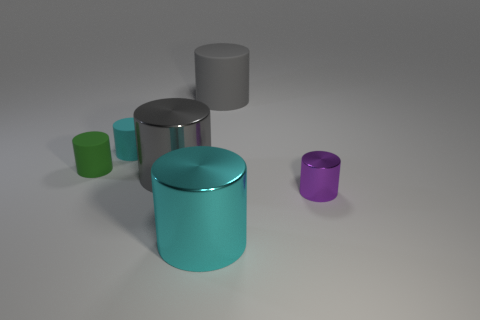What time of day do you think this image is trying to represent? Given the neutral background and the even lighting, it's hard to determine a specific time of day. The image seems to be taken in a controlled indoor environment with artificial lighting. 